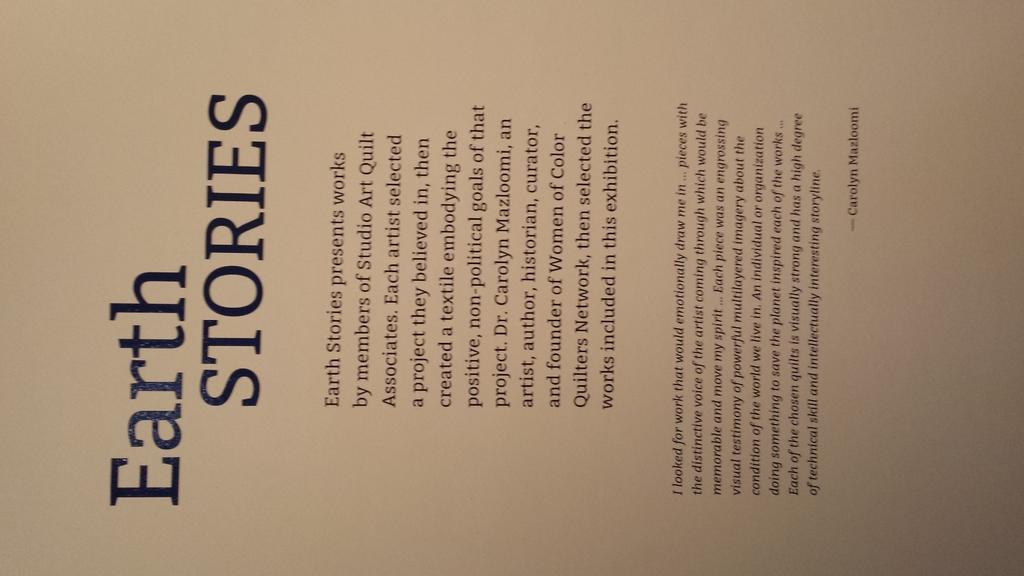<image>
Provide a brief description of the given image. Page of text book called Earth Stories by members of Studio Art Quilt Associates. 